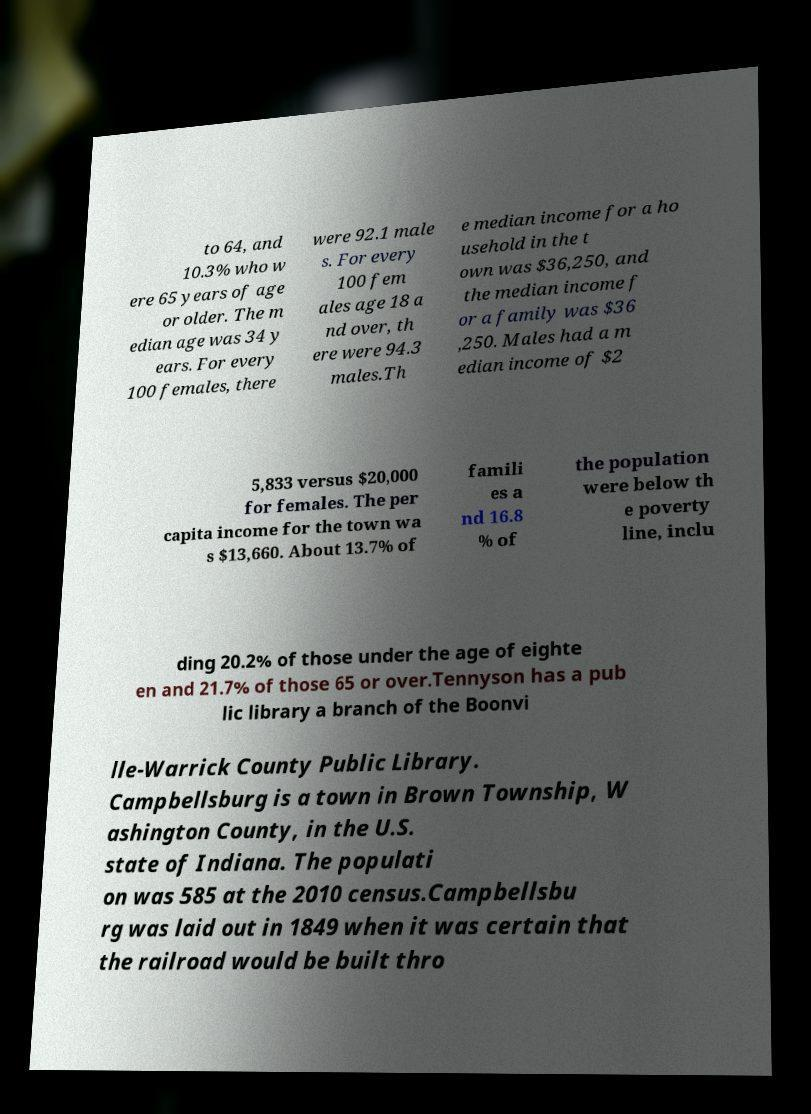Can you accurately transcribe the text from the provided image for me? to 64, and 10.3% who w ere 65 years of age or older. The m edian age was 34 y ears. For every 100 females, there were 92.1 male s. For every 100 fem ales age 18 a nd over, th ere were 94.3 males.Th e median income for a ho usehold in the t own was $36,250, and the median income f or a family was $36 ,250. Males had a m edian income of $2 5,833 versus $20,000 for females. The per capita income for the town wa s $13,660. About 13.7% of famili es a nd 16.8 % of the population were below th e poverty line, inclu ding 20.2% of those under the age of eighte en and 21.7% of those 65 or over.Tennyson has a pub lic library a branch of the Boonvi lle-Warrick County Public Library. Campbellsburg is a town in Brown Township, W ashington County, in the U.S. state of Indiana. The populati on was 585 at the 2010 census.Campbellsbu rg was laid out in 1849 when it was certain that the railroad would be built thro 